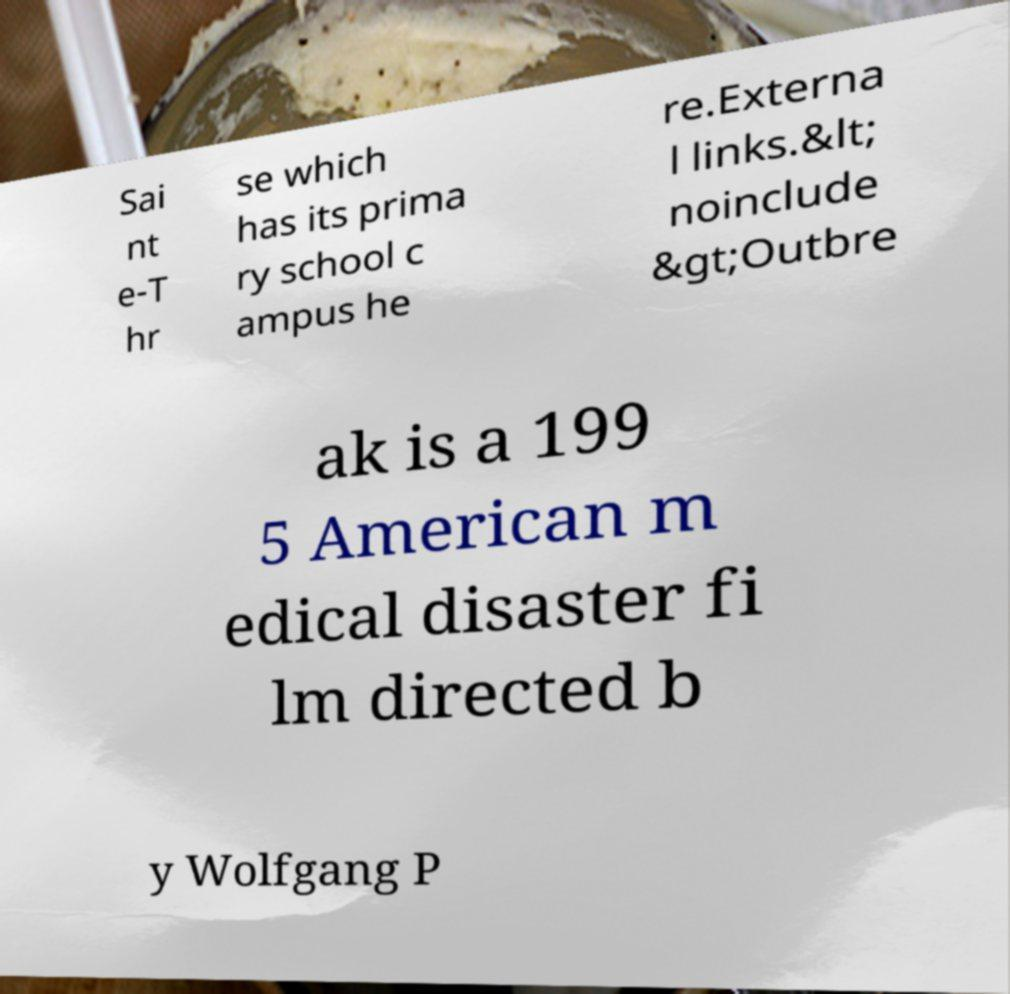Could you assist in decoding the text presented in this image and type it out clearly? Sai nt e-T hr se which has its prima ry school c ampus he re.Externa l links.&lt; noinclude &gt;Outbre ak is a 199 5 American m edical disaster fi lm directed b y Wolfgang P 